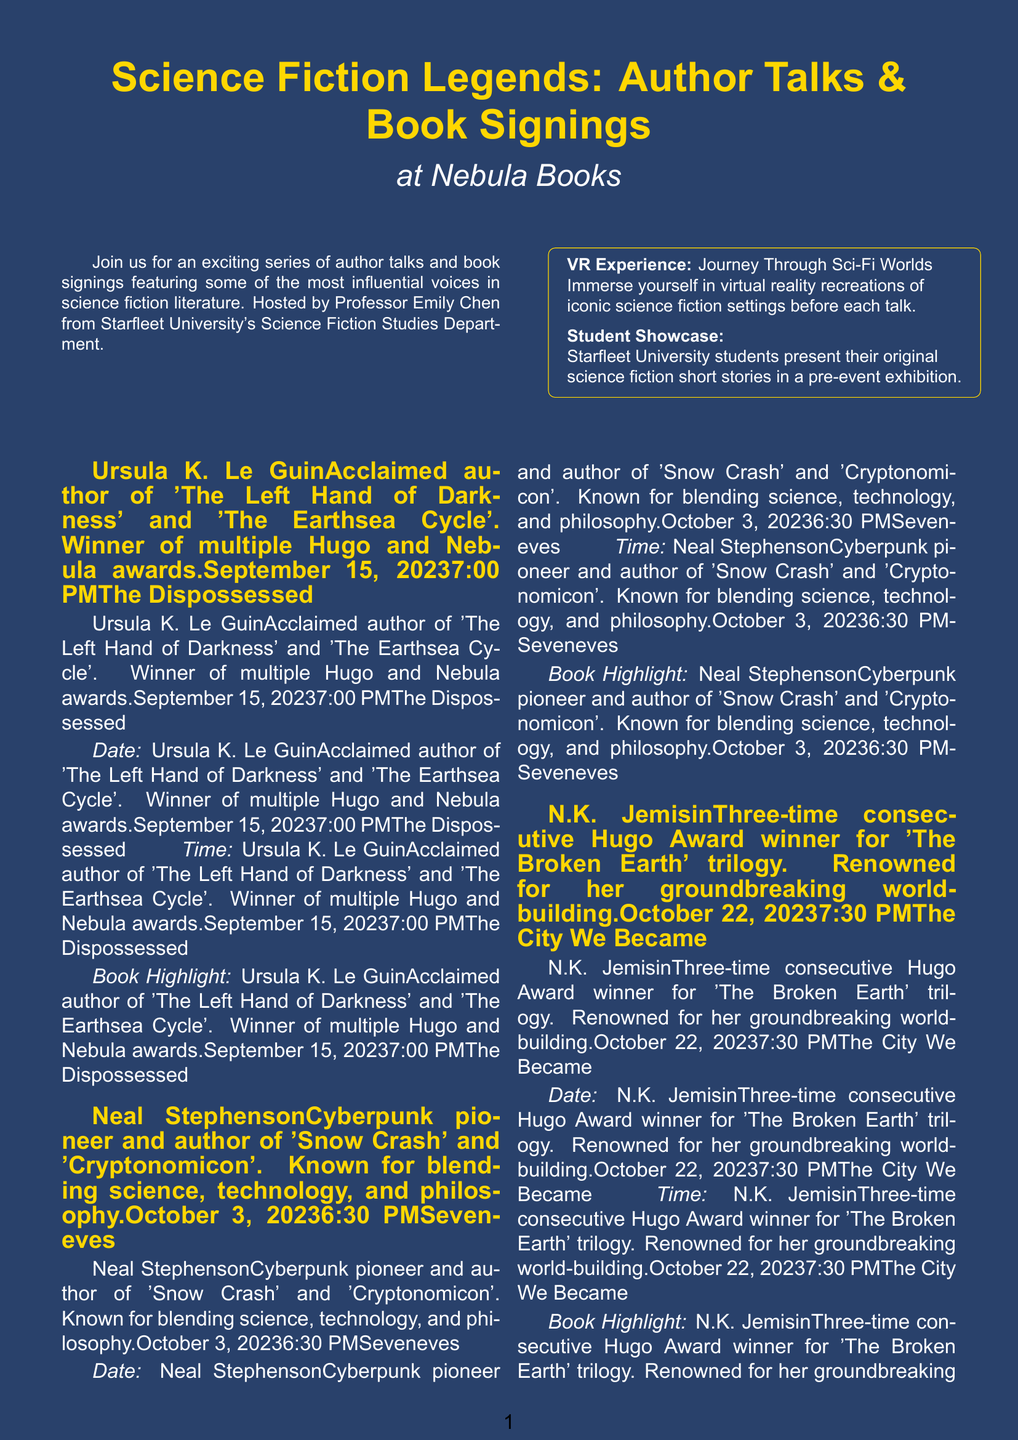What is the title of the brochure? The title of the brochure is the main heading that captures the event's theme, which is "Science Fiction Legends: Author Talks & Book Signings."
Answer: Science Fiction Legends: Author Talks & Book Signings Who is hosting the event? The document specifies the person responsible for hosting the events, which is Professor Emily Chen from Starfleet University.
Answer: Professor Emily Chen What date does Ursula K. Le Guin's event occur? The date is listed next to her name and is crucial for planning attendance.
Answer: September 15, 2023 What is the ticket price for a single event? The brochure provides pricing details, specifically indicating the cost to attend a single event.
Answer: $15 per event Which author is known for the book "Seveneves"? This question requires knowledge of which author is associated with that title mentioned in the brochure.
Answer: Neal Stephenson How many authors are featured in the event series? The total number of authors listed provides insight into the breadth of the event.
Answer: Four What special feature allows interaction before each talk? The unique element described that enhances attendee experience is clearly outlined in the brochure.
Answer: VR Experience: Journey Through Sci-Fi Worlds What benefit do students receive with a valid student ID? The document clarifies specific discounts provided to students, which is relevant for attendance considerations.
Answer: 50% off Where is Nebula Books located? The address provided in the document is essential for identifying the venue of the event.
Answer: 123 Cosmic Avenue, Metropolis, NY 10001 